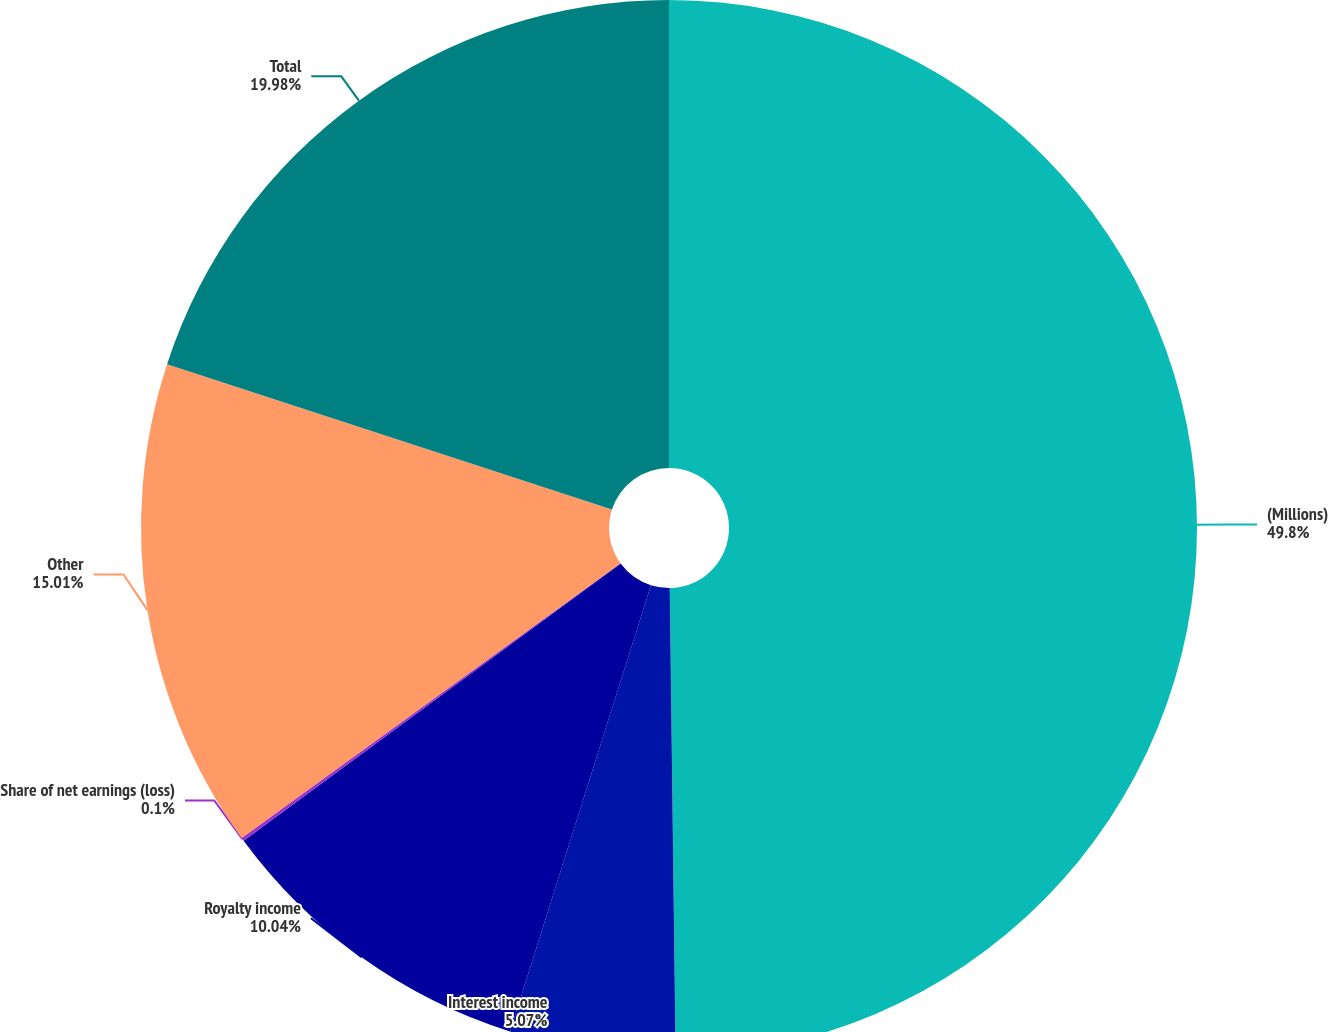Convert chart to OTSL. <chart><loc_0><loc_0><loc_500><loc_500><pie_chart><fcel>(Millions)<fcel>Interest income<fcel>Royalty income<fcel>Share of net earnings (loss)<fcel>Other<fcel>Total<nl><fcel>49.8%<fcel>5.07%<fcel>10.04%<fcel>0.1%<fcel>15.01%<fcel>19.98%<nl></chart> 